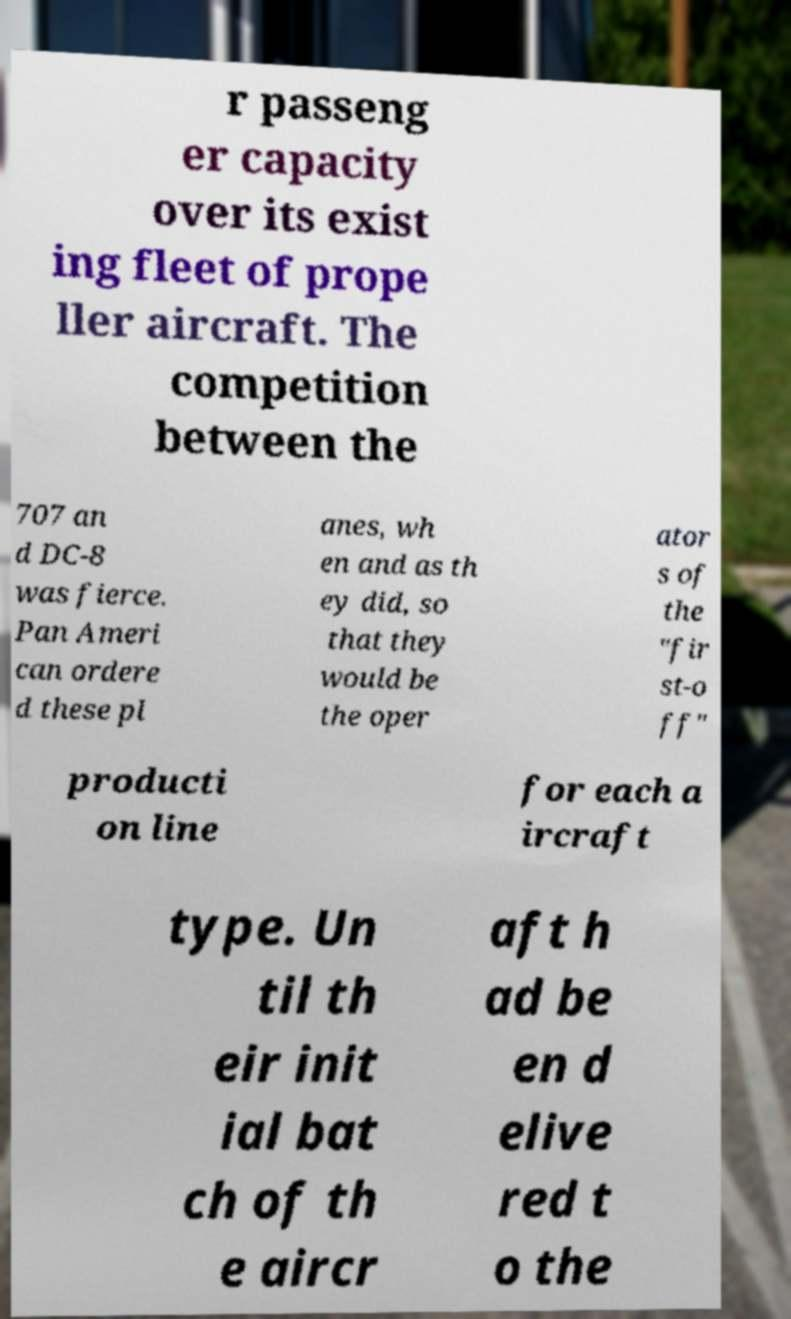Could you extract and type out the text from this image? r passeng er capacity over its exist ing fleet of prope ller aircraft. The competition between the 707 an d DC-8 was fierce. Pan Ameri can ordere d these pl anes, wh en and as th ey did, so that they would be the oper ator s of the "fir st-o ff" producti on line for each a ircraft type. Un til th eir init ial bat ch of th e aircr aft h ad be en d elive red t o the 